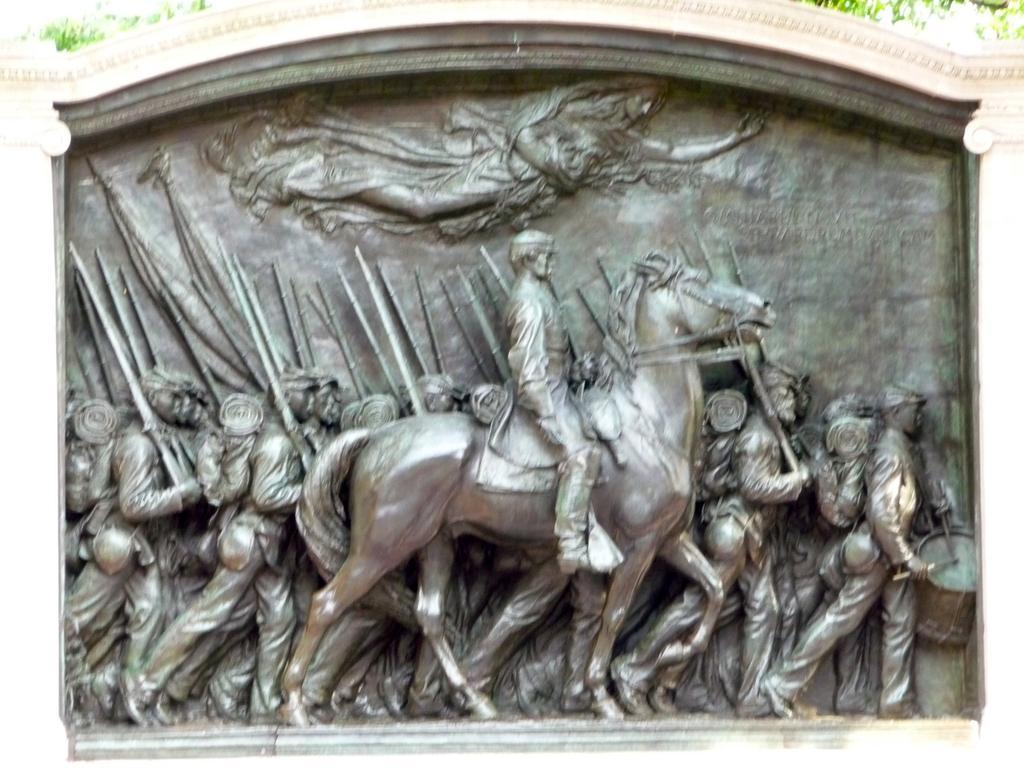In one or two sentences, can you explain what this image depicts? We can see sculpture,there is a person sitting on horse and group of people walking. 